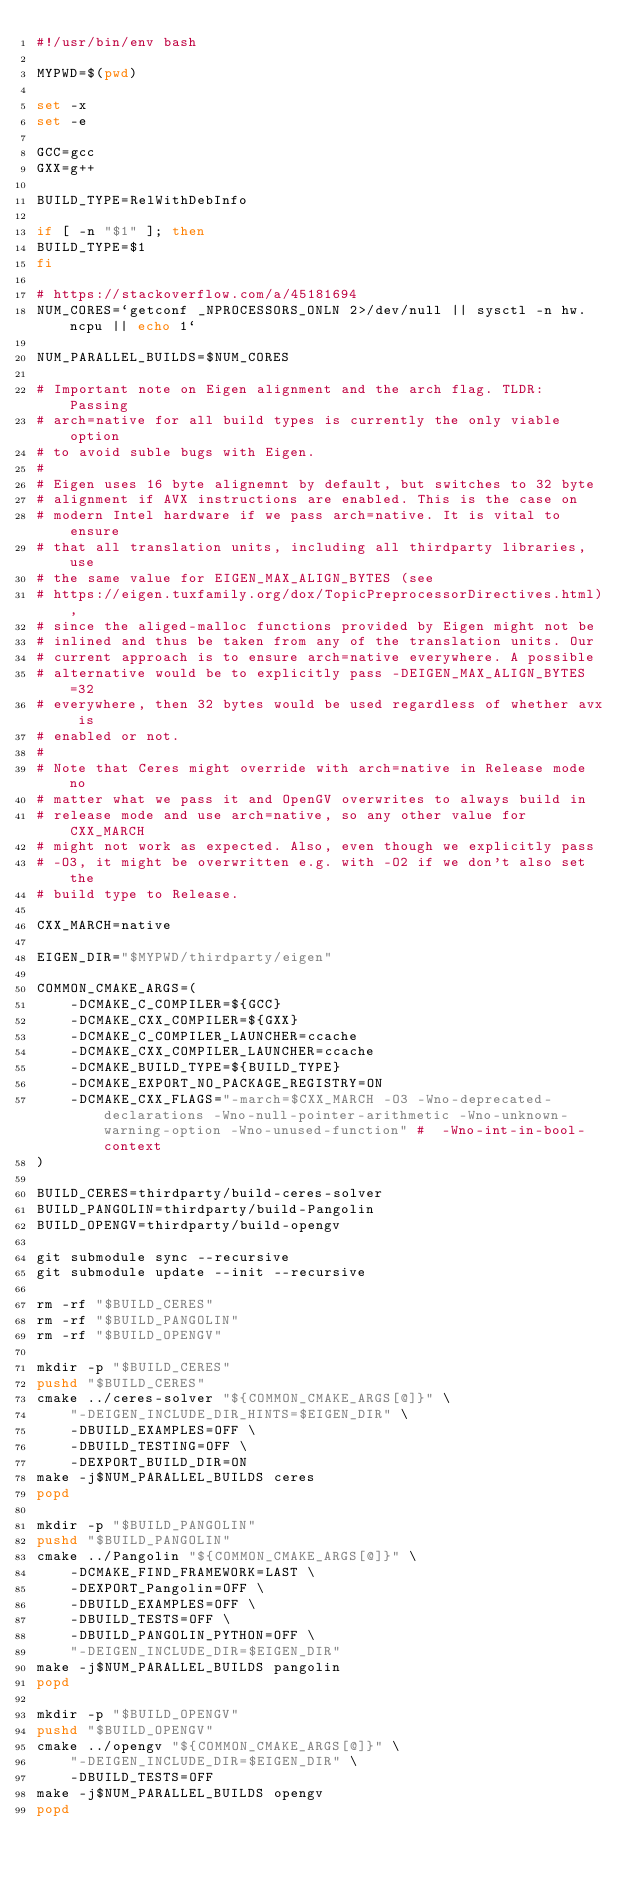<code> <loc_0><loc_0><loc_500><loc_500><_Bash_>#!/usr/bin/env bash

MYPWD=$(pwd)

set -x
set -e

GCC=gcc
GXX=g++

BUILD_TYPE=RelWithDebInfo

if [ -n "$1" ]; then
BUILD_TYPE=$1
fi

# https://stackoverflow.com/a/45181694
NUM_CORES=`getconf _NPROCESSORS_ONLN 2>/dev/null || sysctl -n hw.ncpu || echo 1`

NUM_PARALLEL_BUILDS=$NUM_CORES

# Important note on Eigen alignment and the arch flag. TLDR: Passing
# arch=native for all build types is currently the only viable option
# to avoid suble bugs with Eigen.
#
# Eigen uses 16 byte alignemnt by default, but switches to 32 byte
# alignment if AVX instructions are enabled. This is the case on
# modern Intel hardware if we pass arch=native. It is vital to ensure
# that all translation units, including all thirdparty libraries, use
# the same value for EIGEN_MAX_ALIGN_BYTES (see
# https://eigen.tuxfamily.org/dox/TopicPreprocessorDirectives.html),
# since the aliged-malloc functions provided by Eigen might not be
# inlined and thus be taken from any of the translation units. Our
# current approach is to ensure arch=native everywhere. A possible
# alternative would be to explicitly pass -DEIGEN_MAX_ALIGN_BYTES=32
# everywhere, then 32 bytes would be used regardless of whether avx is
# enabled or not.
#
# Note that Ceres might override with arch=native in Release mode no
# matter what we pass it and OpenGV overwrites to always build in
# release mode and use arch=native, so any other value for CXX_MARCH
# might not work as expected. Also, even though we explicitly pass
# -O3, it might be overwritten e.g. with -O2 if we don't also set the
# build type to Release.

CXX_MARCH=native

EIGEN_DIR="$MYPWD/thirdparty/eigen"

COMMON_CMAKE_ARGS=(
    -DCMAKE_C_COMPILER=${GCC}
    -DCMAKE_CXX_COMPILER=${GXX}
    -DCMAKE_C_COMPILER_LAUNCHER=ccache
    -DCMAKE_CXX_COMPILER_LAUNCHER=ccache
    -DCMAKE_BUILD_TYPE=${BUILD_TYPE}
    -DCMAKE_EXPORT_NO_PACKAGE_REGISTRY=ON
    -DCMAKE_CXX_FLAGS="-march=$CXX_MARCH -O3 -Wno-deprecated-declarations -Wno-null-pointer-arithmetic -Wno-unknown-warning-option -Wno-unused-function" #  -Wno-int-in-bool-context
)

BUILD_CERES=thirdparty/build-ceres-solver
BUILD_PANGOLIN=thirdparty/build-Pangolin
BUILD_OPENGV=thirdparty/build-opengv

git submodule sync --recursive
git submodule update --init --recursive

rm -rf "$BUILD_CERES"
rm -rf "$BUILD_PANGOLIN"
rm -rf "$BUILD_OPENGV"

mkdir -p "$BUILD_CERES"
pushd "$BUILD_CERES"
cmake ../ceres-solver "${COMMON_CMAKE_ARGS[@]}" \
    "-DEIGEN_INCLUDE_DIR_HINTS=$EIGEN_DIR" \
    -DBUILD_EXAMPLES=OFF \
    -DBUILD_TESTING=OFF \
    -DEXPORT_BUILD_DIR=ON
make -j$NUM_PARALLEL_BUILDS ceres
popd

mkdir -p "$BUILD_PANGOLIN"
pushd "$BUILD_PANGOLIN"
cmake ../Pangolin "${COMMON_CMAKE_ARGS[@]}" \
    -DCMAKE_FIND_FRAMEWORK=LAST \
    -DEXPORT_Pangolin=OFF \
    -DBUILD_EXAMPLES=OFF \
    -DBUILD_TESTS=OFF \
    -DBUILD_PANGOLIN_PYTHON=OFF \
    "-DEIGEN_INCLUDE_DIR=$EIGEN_DIR"
make -j$NUM_PARALLEL_BUILDS pangolin
popd

mkdir -p "$BUILD_OPENGV"
pushd "$BUILD_OPENGV"
cmake ../opengv "${COMMON_CMAKE_ARGS[@]}" \
    "-DEIGEN_INCLUDE_DIR=$EIGEN_DIR" \
    -DBUILD_TESTS=OFF
make -j$NUM_PARALLEL_BUILDS opengv
popd
</code> 